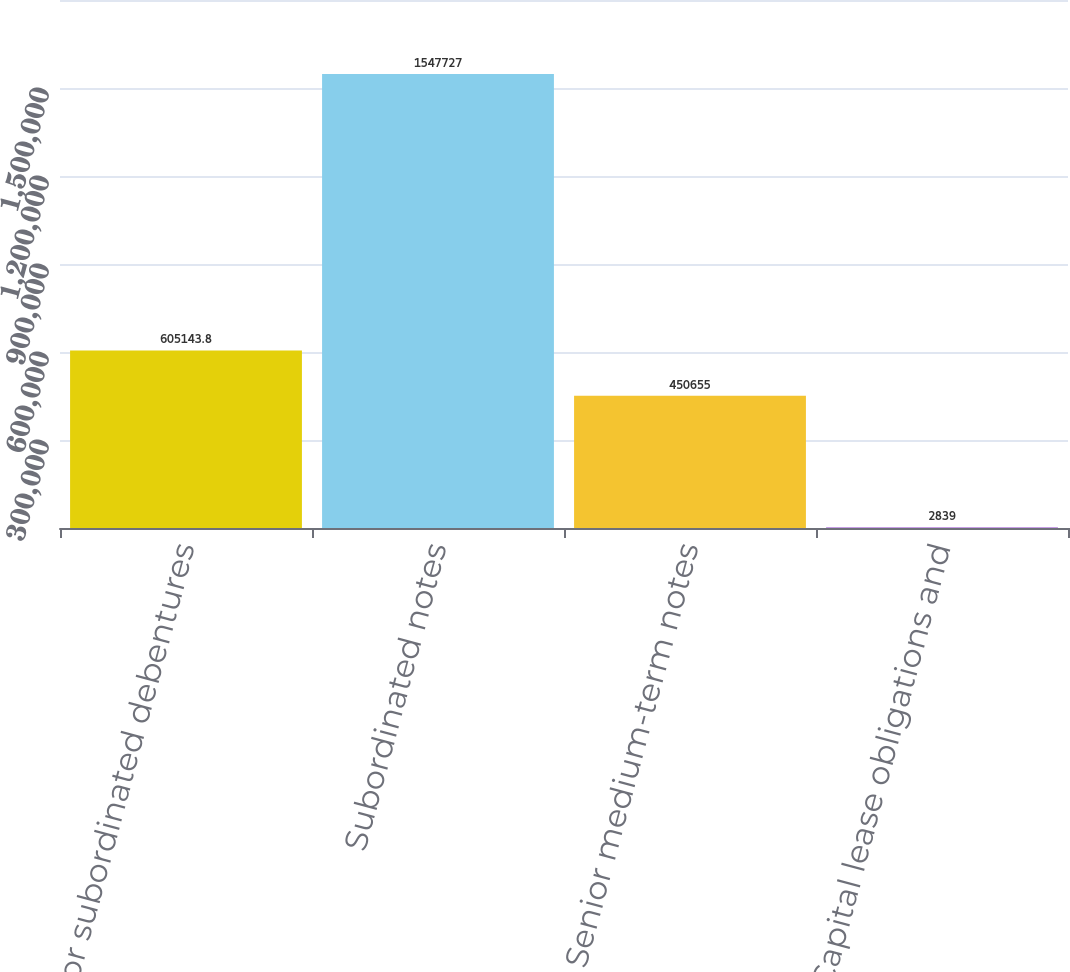Convert chart. <chart><loc_0><loc_0><loc_500><loc_500><bar_chart><fcel>Junior subordinated debentures<fcel>Subordinated notes<fcel>Senior medium-term notes<fcel>Capital lease obligations and<nl><fcel>605144<fcel>1.54773e+06<fcel>450655<fcel>2839<nl></chart> 